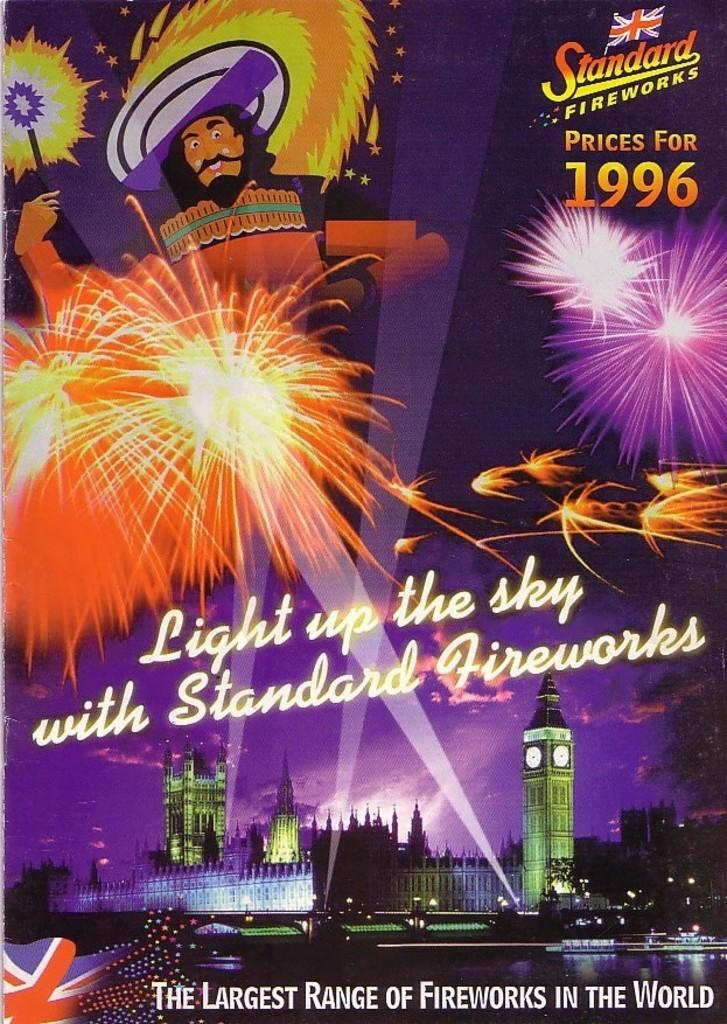<image>
Offer a succinct explanation of the picture presented. The cover of a Standard Fireworks pricing guide for 1996 that shows fireworks over London. 